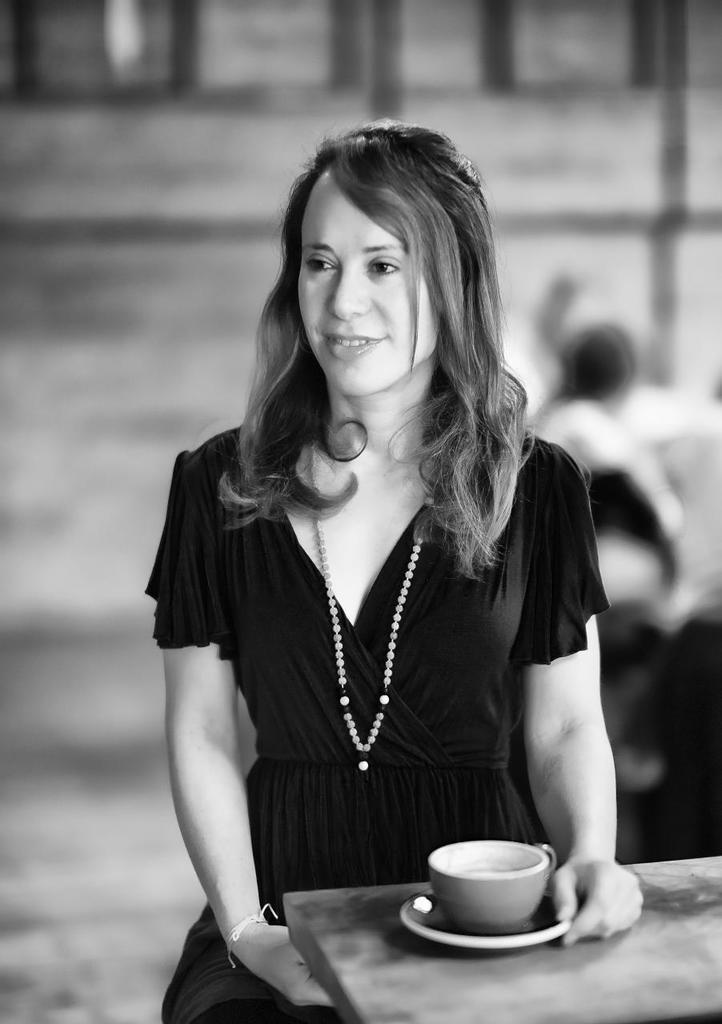Can you describe this image briefly? In this image i can see a woman standing and laughing, in front of a woman cup on a table. 